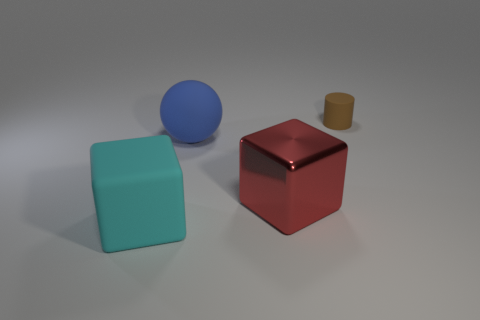Are there the same number of big red metal cubes that are behind the sphere and large cyan rubber objects?
Offer a very short reply. No. There is a metal cube; is its size the same as the cube that is to the left of the red object?
Your answer should be very brief. Yes. What number of large blue spheres are made of the same material as the large red cube?
Provide a succinct answer. 0. Is the size of the red object the same as the matte ball?
Ensure brevity in your answer.  Yes. Is there any other thing of the same color as the small cylinder?
Offer a very short reply. No. The matte thing that is right of the big cyan object and in front of the cylinder has what shape?
Offer a very short reply. Sphere. There is a matte thing in front of the large red metal cube; what is its size?
Provide a short and direct response. Large. There is a big cube right of the cube left of the blue rubber ball; what number of blue matte spheres are on the right side of it?
Give a very brief answer. 0. Are there any tiny matte cylinders on the left side of the cylinder?
Keep it short and to the point. No. How many other things are there of the same size as the cyan object?
Your answer should be very brief. 2. 